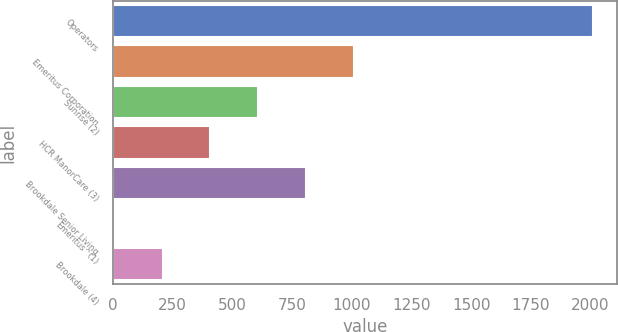Convert chart to OTSL. <chart><loc_0><loc_0><loc_500><loc_500><bar_chart><fcel>Operators<fcel>Emeritus Corporation<fcel>Sunrise (2)<fcel>HCR ManorCare (3)<fcel>Brookdale Senior Living<fcel>Emeritus^(1)<fcel>Brookdale (4)<nl><fcel>2011<fcel>1009<fcel>608.2<fcel>407.8<fcel>808.6<fcel>7<fcel>207.4<nl></chart> 